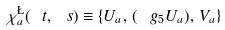Convert formula to latex. <formula><loc_0><loc_0><loc_500><loc_500>\chi ^ { \L } _ { a } ( \ t , \ s ) \equiv \{ U _ { a } , \, ( \ g _ { 5 } U _ { a } ) , \, V _ { a } \}</formula> 